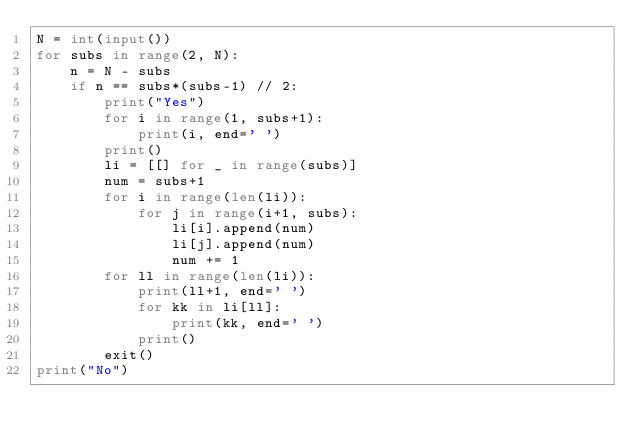<code> <loc_0><loc_0><loc_500><loc_500><_Python_>N = int(input())
for subs in range(2, N):
    n = N - subs
    if n == subs*(subs-1) // 2:
        print("Yes")
        for i in range(1, subs+1):
            print(i, end=' ')
        print()
        li = [[] for _ in range(subs)]
        num = subs+1
        for i in range(len(li)):
            for j in range(i+1, subs):
                li[i].append(num)
                li[j].append(num)
                num += 1
        for ll in range(len(li)):
            print(ll+1, end=' ')
            for kk in li[ll]:
                print(kk, end=' ')
            print()
        exit()
print("No")



</code> 